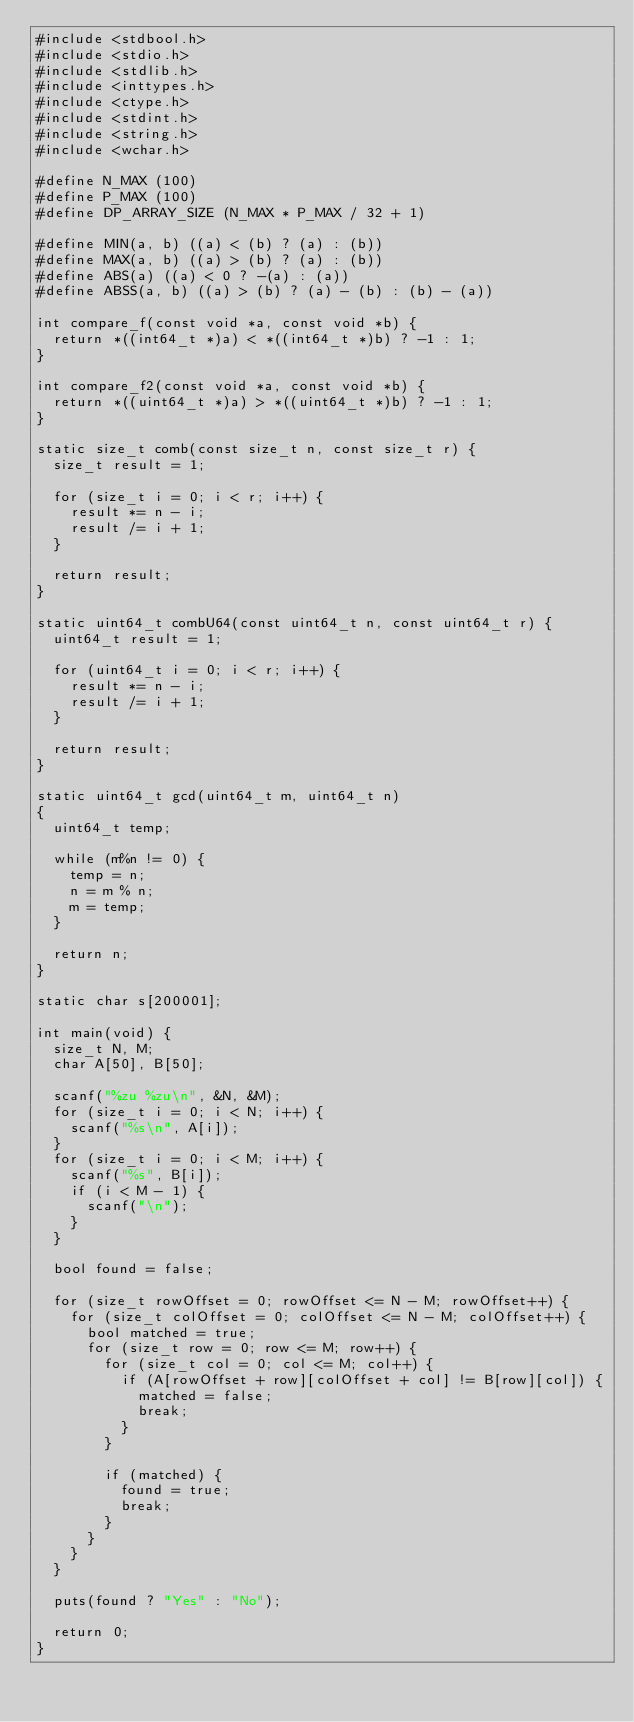<code> <loc_0><loc_0><loc_500><loc_500><_C_>#include <stdbool.h>
#include <stdio.h>
#include <stdlib.h>
#include <inttypes.h>
#include <ctype.h>
#include <stdint.h>
#include <string.h>
#include <wchar.h>

#define N_MAX (100)
#define P_MAX (100)
#define DP_ARRAY_SIZE (N_MAX * P_MAX / 32 + 1)

#define MIN(a, b) ((a) < (b) ? (a) : (b))
#define MAX(a, b) ((a) > (b) ? (a) : (b))
#define ABS(a) ((a) < 0 ? -(a) : (a))
#define ABSS(a, b) ((a) > (b) ? (a) - (b) : (b) - (a))

int compare_f(const void *a, const void *b) {
	return *((int64_t *)a) < *((int64_t *)b) ? -1 : 1;
}

int compare_f2(const void *a, const void *b) {
	return *((uint64_t *)a) > *((uint64_t *)b) ? -1 : 1;
}

static size_t comb(const size_t n, const size_t r) {
	size_t result = 1;

	for (size_t i = 0; i < r; i++) {
		result *= n - i;
		result /= i + 1;
	}

	return result;
}

static uint64_t combU64(const uint64_t n, const uint64_t r) {
	uint64_t result = 1;

	for (uint64_t i = 0; i < r; i++) {
		result *= n - i;
		result /= i + 1;
	}

	return result;
}

static uint64_t gcd(uint64_t m, uint64_t n)
{
	uint64_t temp;

	while (m%n != 0) {
		temp = n;
		n = m % n;
		m = temp;
	}

	return n;
}

static char s[200001];

int main(void) {
	size_t N, M;
	char A[50], B[50];

	scanf("%zu %zu\n", &N, &M);
	for (size_t i = 0; i < N; i++) {
		scanf("%s\n", A[i]);
	}
	for (size_t i = 0; i < M; i++) {
		scanf("%s", B[i]);
		if (i < M - 1) {
			scanf("\n");
		}
	}

	bool found = false;

	for (size_t rowOffset = 0; rowOffset <= N - M; rowOffset++) {
		for (size_t colOffset = 0; colOffset <= N - M; colOffset++) {
			bool matched = true;
			for (size_t row = 0; row <= M; row++) {
				for (size_t col = 0; col <= M; col++) {
					if (A[rowOffset + row][colOffset + col] != B[row][col]) {
						matched = false;
						break;
					}
				}

				if (matched) {
					found = true;
					break;
				}
			}
		}
	}

	puts(found ? "Yes" : "No");

	return 0;
}
</code> 